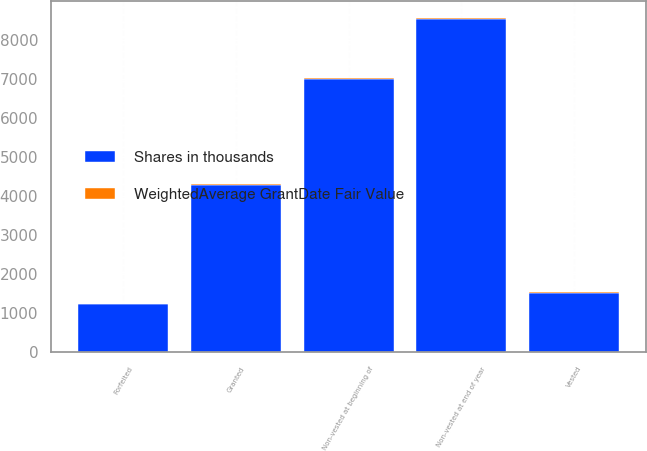Convert chart to OTSL. <chart><loc_0><loc_0><loc_500><loc_500><stacked_bar_chart><ecel><fcel>Non-vested at beginning of<fcel>Granted<fcel>Vested<fcel>Forfeited<fcel>Non-vested at end of year<nl><fcel>Shares in thousands<fcel>6991<fcel>4291<fcel>1511<fcel>1228<fcel>8543<nl><fcel>WeightedAverage GrantDate Fair Value<fcel>22.98<fcel>26.61<fcel>25.54<fcel>22.86<fcel>24.37<nl></chart> 